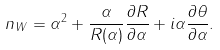<formula> <loc_0><loc_0><loc_500><loc_500>n _ { W } = \alpha ^ { 2 } + \frac { \alpha } { R ( \alpha ) } \frac { \partial R } { \partial \alpha } + i \alpha \frac { \partial \theta } { \partial \alpha } .</formula> 